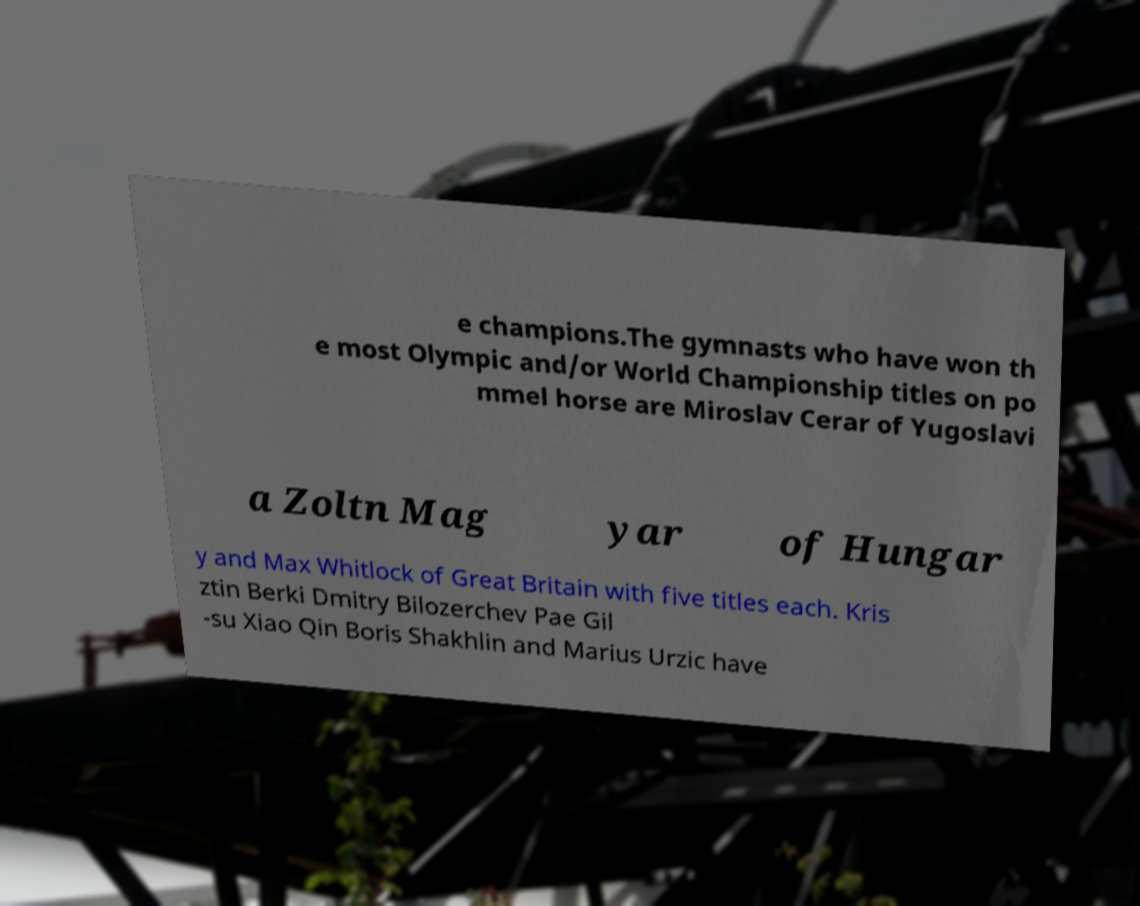Could you extract and type out the text from this image? e champions.The gymnasts who have won th e most Olympic and/or World Championship titles on po mmel horse are Miroslav Cerar of Yugoslavi a Zoltn Mag yar of Hungar y and Max Whitlock of Great Britain with five titles each. Kris ztin Berki Dmitry Bilozerchev Pae Gil -su Xiao Qin Boris Shakhlin and Marius Urzic have 